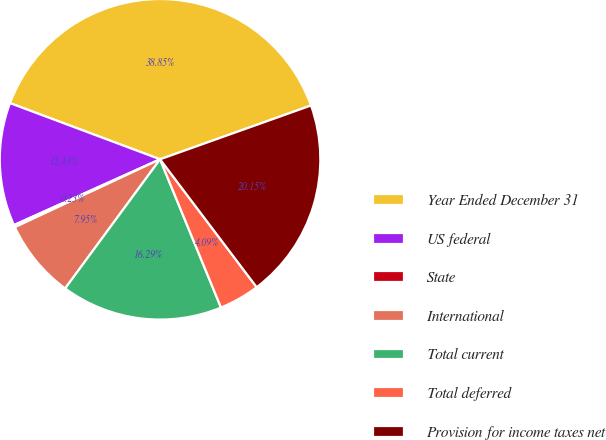<chart> <loc_0><loc_0><loc_500><loc_500><pie_chart><fcel>Year Ended December 31<fcel>US federal<fcel>State<fcel>International<fcel>Total current<fcel>Total deferred<fcel>Provision for income taxes net<nl><fcel>38.84%<fcel>12.43%<fcel>0.23%<fcel>7.95%<fcel>16.29%<fcel>4.09%<fcel>20.15%<nl></chart> 